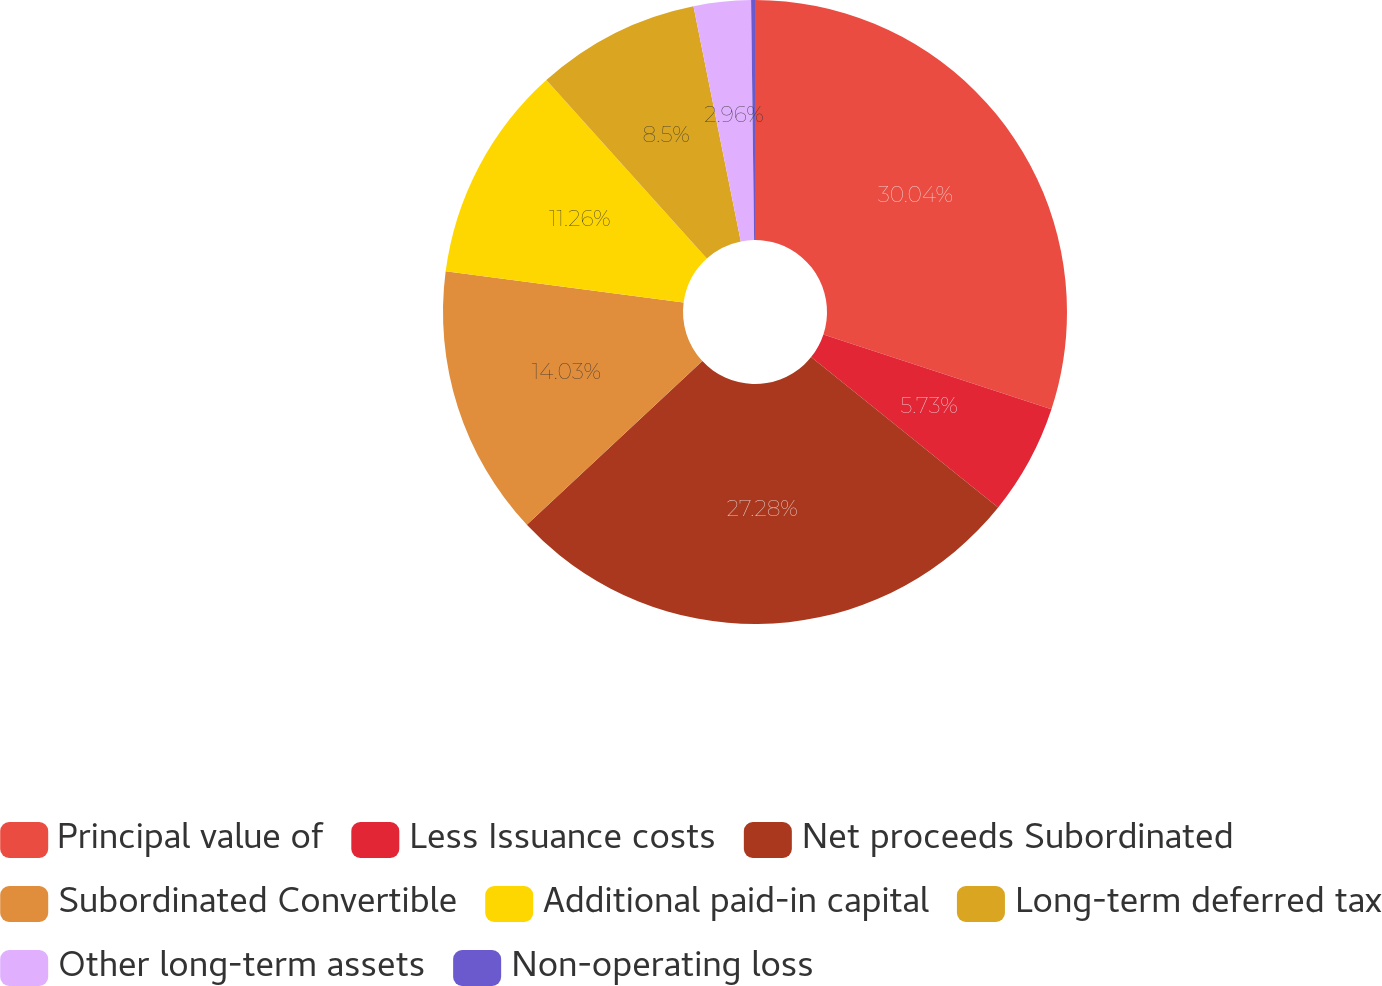<chart> <loc_0><loc_0><loc_500><loc_500><pie_chart><fcel>Principal value of<fcel>Less Issuance costs<fcel>Net proceeds Subordinated<fcel>Subordinated Convertible<fcel>Additional paid-in capital<fcel>Long-term deferred tax<fcel>Other long-term assets<fcel>Non-operating loss<nl><fcel>30.05%<fcel>5.73%<fcel>27.28%<fcel>14.03%<fcel>11.26%<fcel>8.5%<fcel>2.96%<fcel>0.2%<nl></chart> 